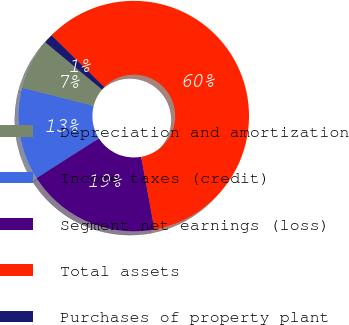Convert chart to OTSL. <chart><loc_0><loc_0><loc_500><loc_500><pie_chart><fcel>Depreciation and amortization<fcel>Income taxes (credit)<fcel>Segment net earnings (loss)<fcel>Total assets<fcel>Purchases of property plant<nl><fcel>7.13%<fcel>12.98%<fcel>18.83%<fcel>59.78%<fcel>1.28%<nl></chart> 